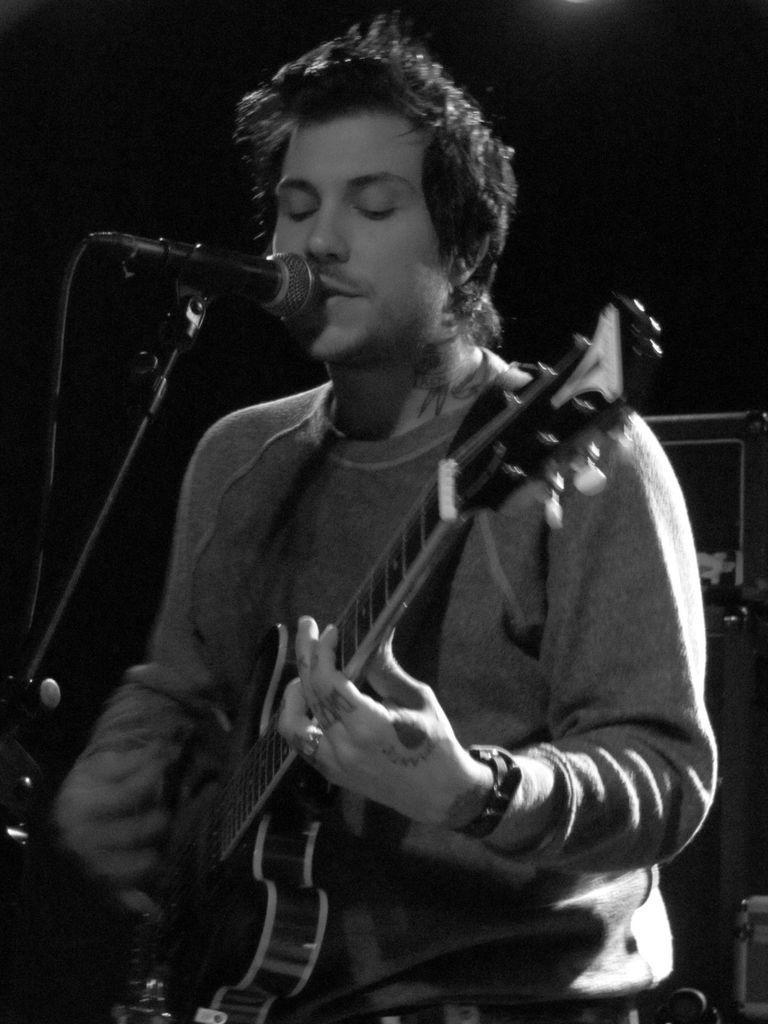Describe this image in one or two sentences. In the image we can see there is a man who is standing and holding guitar in his hand and in front of him there is mic with a stand and the image is in black and white colour. 